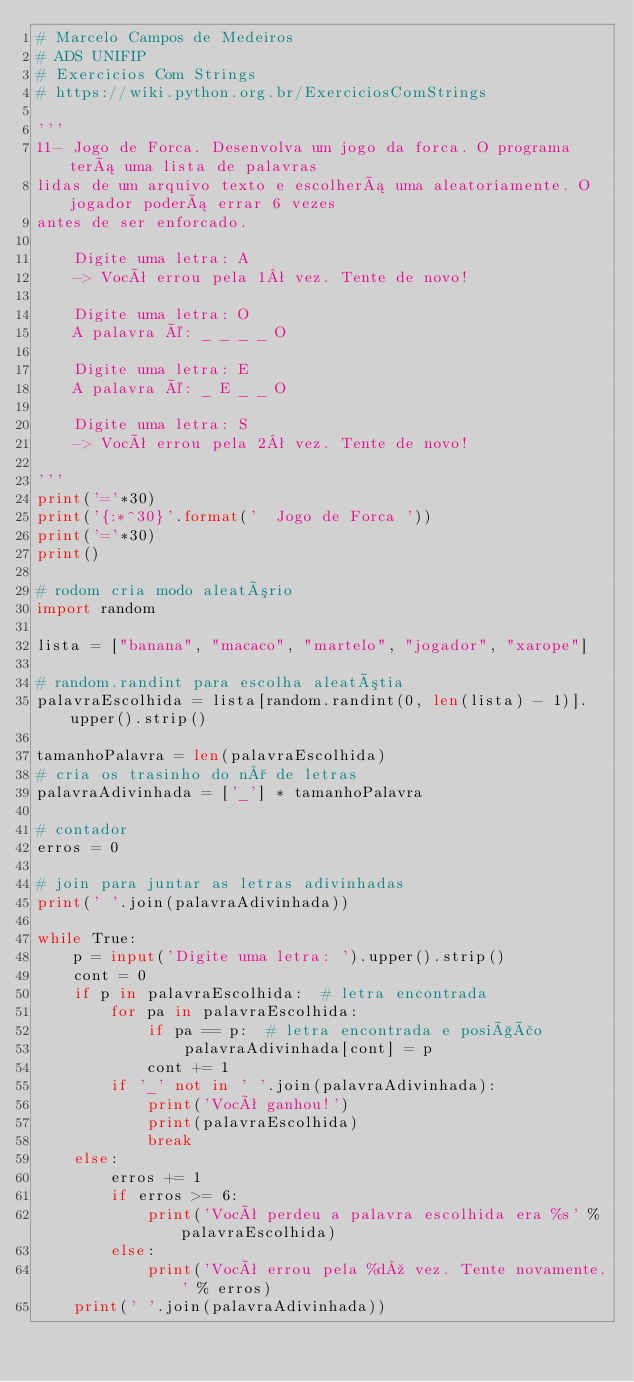<code> <loc_0><loc_0><loc_500><loc_500><_Python_># Marcelo Campos de Medeiros
# ADS UNIFIP
# Exercicios Com Strings
# https://wiki.python.org.br/ExerciciosComStrings

'''
11- Jogo de Forca. Desenvolva um jogo da forca. O programa terá uma lista de palavras 
lidas de um arquivo texto e escolherá uma aleatoriamente. O jogador poderá errar 6 vezes 
antes de ser enforcado.

    Digite uma letra: A
    -> Você errou pela 1ª vez. Tente de novo!

    Digite uma letra: O
    A palavra é: _ _ _ _ O

    Digite uma letra: E
    A palavra é: _ E _ _ O

    Digite uma letra: S
    -> Você errou pela 2ª vez. Tente de novo!

'''
print('='*30)
print('{:*^30}'.format('  Jogo de Forca '))
print('='*30)
print()

# rodom cria modo aleatório
import random

lista = ["banana", "macaco", "martelo", "jogador", "xarope"]

# random.randint para escolha aleatótia
palavraEscolhida = lista[random.randint(0, len(lista) - 1)].upper().strip()

tamanhoPalavra = len(palavraEscolhida)
# cria os trasinho do n° de letras
palavraAdivinhada = ['_'] * tamanhoPalavra

# contador
erros = 0

# join para juntar as letras adivinhadas
print(' '.join(palavraAdivinhada))

while True:
    p = input('Digite uma letra: ').upper().strip()
    cont = 0
    if p in palavraEscolhida:  # letra encontrada
        for pa in palavraEscolhida:
            if pa == p:  # letra encontrada e posição
                palavraAdivinhada[cont] = p
            cont += 1
        if '_' not in ' '.join(palavraAdivinhada):
            print('Você ganhou!')
            print(palavraEscolhida)
            break
    else:
        erros += 1
        if erros >= 6:
            print('Você perdeu a palavra escolhida era %s' % palavraEscolhida)
        else:
            print('Você errou pela %dº vez. Tente novamente.' % erros)
    print(' '.join(palavraAdivinhada))
</code> 